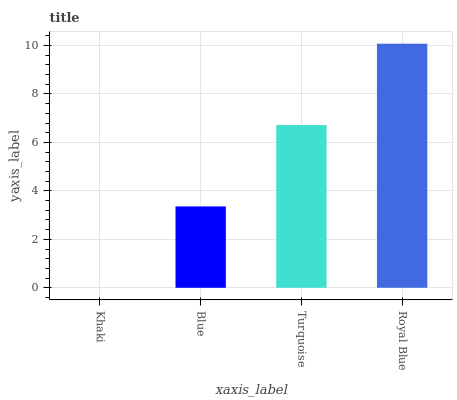Is Blue the minimum?
Answer yes or no. No. Is Blue the maximum?
Answer yes or no. No. Is Blue greater than Khaki?
Answer yes or no. Yes. Is Khaki less than Blue?
Answer yes or no. Yes. Is Khaki greater than Blue?
Answer yes or no. No. Is Blue less than Khaki?
Answer yes or no. No. Is Turquoise the high median?
Answer yes or no. Yes. Is Blue the low median?
Answer yes or no. Yes. Is Khaki the high median?
Answer yes or no. No. Is Turquoise the low median?
Answer yes or no. No. 